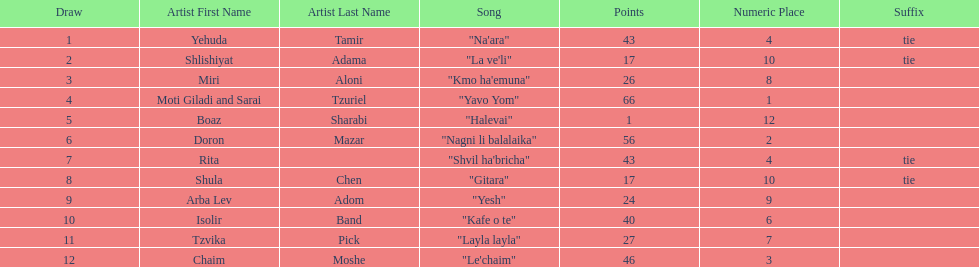Which artist had almost no points? Boaz Sharabi. 